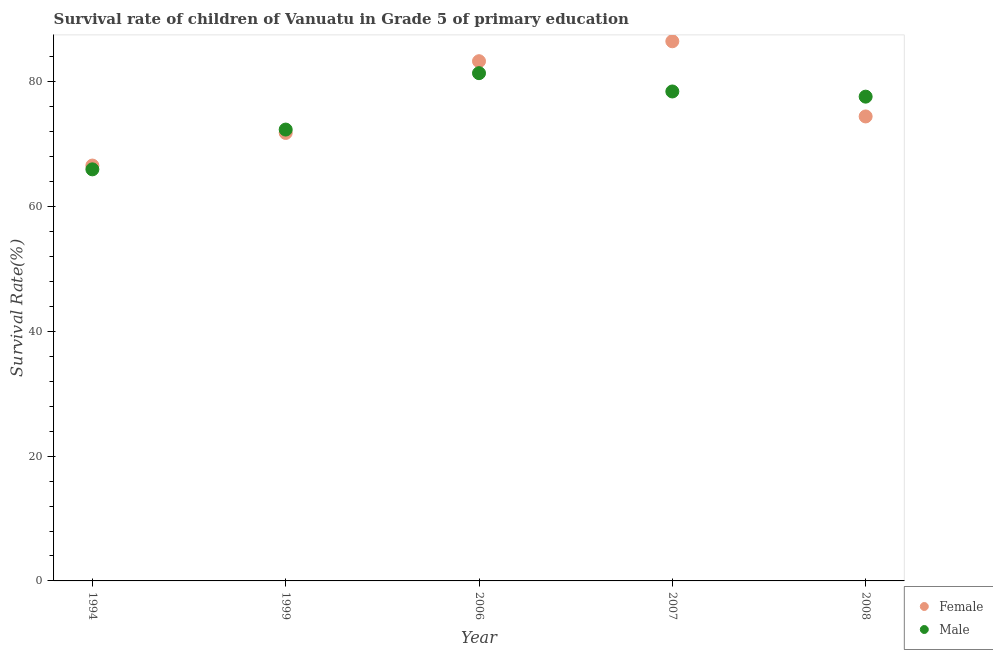What is the survival rate of male students in primary education in 2007?
Give a very brief answer. 78.47. Across all years, what is the maximum survival rate of female students in primary education?
Offer a very short reply. 86.51. Across all years, what is the minimum survival rate of female students in primary education?
Offer a terse response. 66.59. In which year was the survival rate of male students in primary education maximum?
Give a very brief answer. 2006. What is the total survival rate of male students in primary education in the graph?
Your answer should be very brief. 375.85. What is the difference between the survival rate of female students in primary education in 2007 and that in 2008?
Give a very brief answer. 12.05. What is the difference between the survival rate of female students in primary education in 1994 and the survival rate of male students in primary education in 1999?
Offer a very short reply. -5.77. What is the average survival rate of male students in primary education per year?
Offer a very short reply. 75.17. In the year 2008, what is the difference between the survival rate of male students in primary education and survival rate of female students in primary education?
Your response must be concise. 3.17. In how many years, is the survival rate of male students in primary education greater than 32 %?
Offer a very short reply. 5. What is the ratio of the survival rate of female students in primary education in 2007 to that in 2008?
Your response must be concise. 1.16. Is the survival rate of female students in primary education in 2006 less than that in 2007?
Your answer should be compact. Yes. What is the difference between the highest and the second highest survival rate of female students in primary education?
Provide a succinct answer. 3.19. What is the difference between the highest and the lowest survival rate of female students in primary education?
Offer a very short reply. 19.92. In how many years, is the survival rate of female students in primary education greater than the average survival rate of female students in primary education taken over all years?
Offer a terse response. 2. Is the sum of the survival rate of female students in primary education in 1999 and 2008 greater than the maximum survival rate of male students in primary education across all years?
Your answer should be very brief. Yes. Does the survival rate of female students in primary education monotonically increase over the years?
Give a very brief answer. No. Is the survival rate of female students in primary education strictly greater than the survival rate of male students in primary education over the years?
Offer a very short reply. No. Are the values on the major ticks of Y-axis written in scientific E-notation?
Make the answer very short. No. Where does the legend appear in the graph?
Provide a short and direct response. Bottom right. What is the title of the graph?
Keep it short and to the point. Survival rate of children of Vanuatu in Grade 5 of primary education. Does "Fixed telephone" appear as one of the legend labels in the graph?
Your answer should be very brief. No. What is the label or title of the X-axis?
Your response must be concise. Year. What is the label or title of the Y-axis?
Give a very brief answer. Survival Rate(%). What is the Survival Rate(%) in Female in 1994?
Your answer should be very brief. 66.59. What is the Survival Rate(%) in Male in 1994?
Provide a succinct answer. 65.98. What is the Survival Rate(%) in Female in 1999?
Your answer should be very brief. 71.82. What is the Survival Rate(%) of Male in 1999?
Give a very brief answer. 72.36. What is the Survival Rate(%) of Female in 2006?
Provide a succinct answer. 83.32. What is the Survival Rate(%) of Male in 2006?
Your answer should be compact. 81.4. What is the Survival Rate(%) in Female in 2007?
Offer a terse response. 86.51. What is the Survival Rate(%) of Male in 2007?
Ensure brevity in your answer.  78.47. What is the Survival Rate(%) of Female in 2008?
Make the answer very short. 74.46. What is the Survival Rate(%) of Male in 2008?
Your answer should be compact. 77.64. Across all years, what is the maximum Survival Rate(%) in Female?
Your answer should be compact. 86.51. Across all years, what is the maximum Survival Rate(%) of Male?
Your answer should be compact. 81.4. Across all years, what is the minimum Survival Rate(%) in Female?
Your answer should be very brief. 66.59. Across all years, what is the minimum Survival Rate(%) in Male?
Make the answer very short. 65.98. What is the total Survival Rate(%) of Female in the graph?
Give a very brief answer. 382.7. What is the total Survival Rate(%) in Male in the graph?
Your answer should be very brief. 375.85. What is the difference between the Survival Rate(%) in Female in 1994 and that in 1999?
Your answer should be very brief. -5.23. What is the difference between the Survival Rate(%) in Male in 1994 and that in 1999?
Provide a short and direct response. -6.38. What is the difference between the Survival Rate(%) of Female in 1994 and that in 2006?
Provide a succinct answer. -16.73. What is the difference between the Survival Rate(%) in Male in 1994 and that in 2006?
Make the answer very short. -15.42. What is the difference between the Survival Rate(%) of Female in 1994 and that in 2007?
Offer a terse response. -19.92. What is the difference between the Survival Rate(%) in Male in 1994 and that in 2007?
Offer a terse response. -12.48. What is the difference between the Survival Rate(%) in Female in 1994 and that in 2008?
Your answer should be compact. -7.87. What is the difference between the Survival Rate(%) of Male in 1994 and that in 2008?
Your answer should be compact. -11.65. What is the difference between the Survival Rate(%) of Female in 1999 and that in 2006?
Ensure brevity in your answer.  -11.5. What is the difference between the Survival Rate(%) in Male in 1999 and that in 2006?
Keep it short and to the point. -9.04. What is the difference between the Survival Rate(%) in Female in 1999 and that in 2007?
Offer a terse response. -14.7. What is the difference between the Survival Rate(%) of Male in 1999 and that in 2007?
Provide a succinct answer. -6.11. What is the difference between the Survival Rate(%) of Female in 1999 and that in 2008?
Make the answer very short. -2.65. What is the difference between the Survival Rate(%) in Male in 1999 and that in 2008?
Give a very brief answer. -5.28. What is the difference between the Survival Rate(%) in Female in 2006 and that in 2007?
Ensure brevity in your answer.  -3.19. What is the difference between the Survival Rate(%) in Male in 2006 and that in 2007?
Your answer should be very brief. 2.93. What is the difference between the Survival Rate(%) in Female in 2006 and that in 2008?
Ensure brevity in your answer.  8.86. What is the difference between the Survival Rate(%) in Male in 2006 and that in 2008?
Your answer should be compact. 3.76. What is the difference between the Survival Rate(%) of Female in 2007 and that in 2008?
Offer a terse response. 12.05. What is the difference between the Survival Rate(%) in Male in 2007 and that in 2008?
Offer a terse response. 0.83. What is the difference between the Survival Rate(%) of Female in 1994 and the Survival Rate(%) of Male in 1999?
Ensure brevity in your answer.  -5.77. What is the difference between the Survival Rate(%) of Female in 1994 and the Survival Rate(%) of Male in 2006?
Provide a succinct answer. -14.81. What is the difference between the Survival Rate(%) of Female in 1994 and the Survival Rate(%) of Male in 2007?
Offer a very short reply. -11.88. What is the difference between the Survival Rate(%) of Female in 1994 and the Survival Rate(%) of Male in 2008?
Your answer should be compact. -11.05. What is the difference between the Survival Rate(%) of Female in 1999 and the Survival Rate(%) of Male in 2006?
Your response must be concise. -9.58. What is the difference between the Survival Rate(%) in Female in 1999 and the Survival Rate(%) in Male in 2007?
Give a very brief answer. -6.65. What is the difference between the Survival Rate(%) in Female in 1999 and the Survival Rate(%) in Male in 2008?
Your answer should be very brief. -5.82. What is the difference between the Survival Rate(%) of Female in 2006 and the Survival Rate(%) of Male in 2007?
Give a very brief answer. 4.85. What is the difference between the Survival Rate(%) of Female in 2006 and the Survival Rate(%) of Male in 2008?
Offer a very short reply. 5.68. What is the difference between the Survival Rate(%) of Female in 2007 and the Survival Rate(%) of Male in 2008?
Make the answer very short. 8.88. What is the average Survival Rate(%) in Female per year?
Give a very brief answer. 76.54. What is the average Survival Rate(%) of Male per year?
Provide a short and direct response. 75.17. In the year 1994, what is the difference between the Survival Rate(%) in Female and Survival Rate(%) in Male?
Ensure brevity in your answer.  0.61. In the year 1999, what is the difference between the Survival Rate(%) in Female and Survival Rate(%) in Male?
Your answer should be compact. -0.54. In the year 2006, what is the difference between the Survival Rate(%) of Female and Survival Rate(%) of Male?
Offer a terse response. 1.92. In the year 2007, what is the difference between the Survival Rate(%) of Female and Survival Rate(%) of Male?
Offer a very short reply. 8.05. In the year 2008, what is the difference between the Survival Rate(%) in Female and Survival Rate(%) in Male?
Give a very brief answer. -3.17. What is the ratio of the Survival Rate(%) of Female in 1994 to that in 1999?
Offer a terse response. 0.93. What is the ratio of the Survival Rate(%) in Male in 1994 to that in 1999?
Your answer should be very brief. 0.91. What is the ratio of the Survival Rate(%) of Female in 1994 to that in 2006?
Your answer should be very brief. 0.8. What is the ratio of the Survival Rate(%) in Male in 1994 to that in 2006?
Provide a succinct answer. 0.81. What is the ratio of the Survival Rate(%) of Female in 1994 to that in 2007?
Provide a short and direct response. 0.77. What is the ratio of the Survival Rate(%) of Male in 1994 to that in 2007?
Your answer should be compact. 0.84. What is the ratio of the Survival Rate(%) of Female in 1994 to that in 2008?
Your answer should be compact. 0.89. What is the ratio of the Survival Rate(%) of Male in 1994 to that in 2008?
Provide a short and direct response. 0.85. What is the ratio of the Survival Rate(%) of Female in 1999 to that in 2006?
Offer a terse response. 0.86. What is the ratio of the Survival Rate(%) of Female in 1999 to that in 2007?
Provide a succinct answer. 0.83. What is the ratio of the Survival Rate(%) of Male in 1999 to that in 2007?
Your response must be concise. 0.92. What is the ratio of the Survival Rate(%) of Female in 1999 to that in 2008?
Your response must be concise. 0.96. What is the ratio of the Survival Rate(%) in Male in 1999 to that in 2008?
Keep it short and to the point. 0.93. What is the ratio of the Survival Rate(%) in Female in 2006 to that in 2007?
Give a very brief answer. 0.96. What is the ratio of the Survival Rate(%) in Male in 2006 to that in 2007?
Provide a short and direct response. 1.04. What is the ratio of the Survival Rate(%) of Female in 2006 to that in 2008?
Keep it short and to the point. 1.12. What is the ratio of the Survival Rate(%) of Male in 2006 to that in 2008?
Your response must be concise. 1.05. What is the ratio of the Survival Rate(%) of Female in 2007 to that in 2008?
Offer a terse response. 1.16. What is the ratio of the Survival Rate(%) of Male in 2007 to that in 2008?
Your response must be concise. 1.01. What is the difference between the highest and the second highest Survival Rate(%) of Female?
Your response must be concise. 3.19. What is the difference between the highest and the second highest Survival Rate(%) of Male?
Provide a succinct answer. 2.93. What is the difference between the highest and the lowest Survival Rate(%) of Female?
Ensure brevity in your answer.  19.92. What is the difference between the highest and the lowest Survival Rate(%) of Male?
Offer a very short reply. 15.42. 